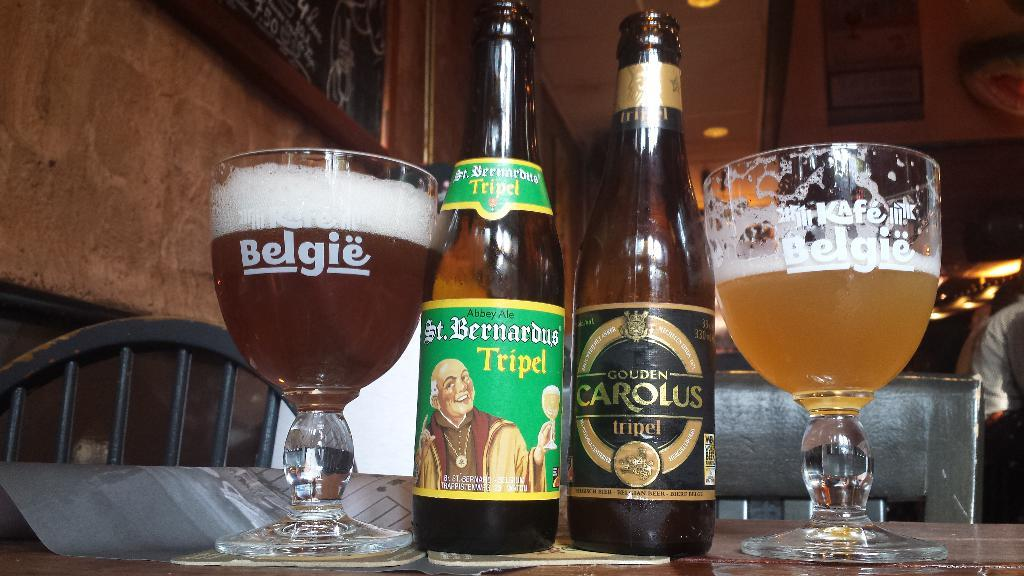<image>
Relay a brief, clear account of the picture shown. A glass full of beer reads Belgie on the side. 